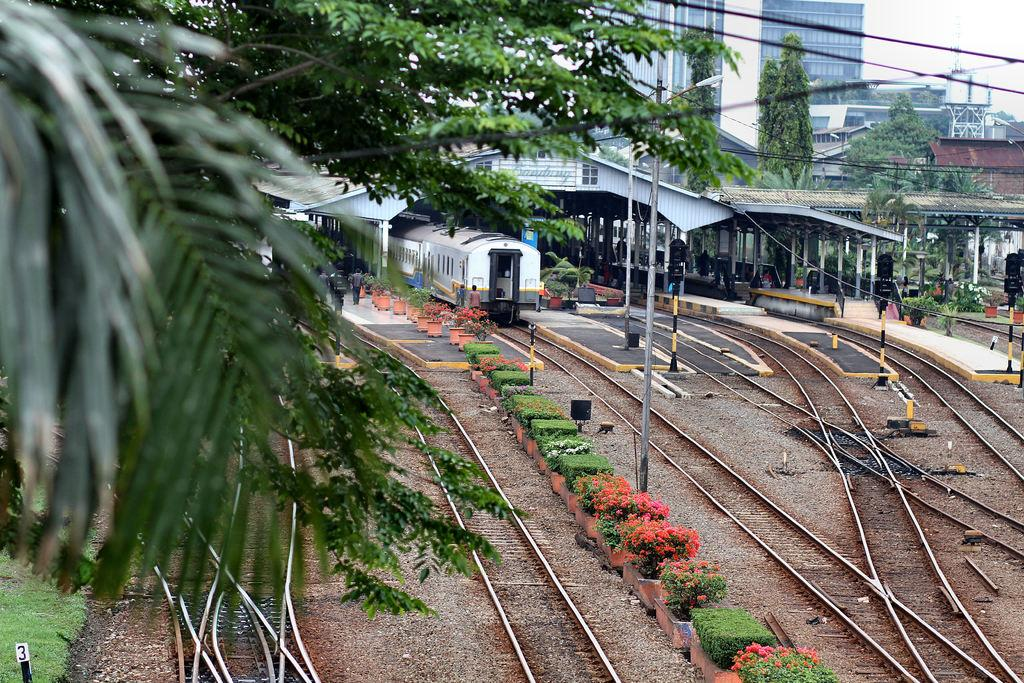What type of transportation infrastructure is visible in the image? There are train tracks in the image. What type of vegetation can be seen in the image? There are plants and trees in the image. What objects are present for holding or containing items? There are pots in the image. What structures are present to support the train tracks? There are poles in the image. What type of transportation vehicle is visible in the image? There is a train in the image. What structures are present for passengers to board or disembark the train? There are platforms in the image. Are there any people visible in the image? Yes, there are people in the image. What can be seen in the background of the image? The background of the image includes buildings, trees, and sky. What type of vegetable is being harvested by the people in the image? There is no vegetable being harvested in the image; the people are not engaged in any agricultural activity. What type of event is taking place in the image? There is no specific event taking place in the image; it is a general scene of a train station with people, train tracks, and a train. 